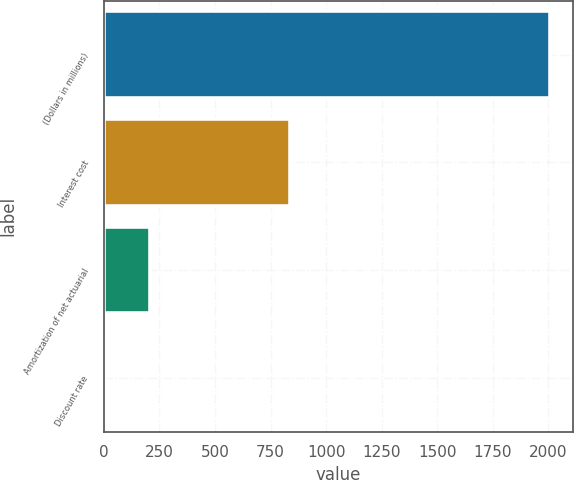Convert chart to OTSL. <chart><loc_0><loc_0><loc_500><loc_500><bar_chart><fcel>(Dollars in millions)<fcel>Interest cost<fcel>Amortization of net actuarial<fcel>Discount rate<nl><fcel>2008<fcel>837<fcel>206.2<fcel>6<nl></chart> 